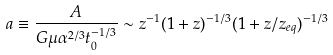Convert formula to latex. <formula><loc_0><loc_0><loc_500><loc_500>a \equiv \frac { A } { G \mu \alpha ^ { 2 / 3 } t _ { 0 } ^ { - 1 / 3 } } \sim z ^ { - 1 } ( 1 + z ) ^ { - 1 / 3 } ( 1 + z / z _ { e q } ) ^ { - 1 / 3 }</formula> 